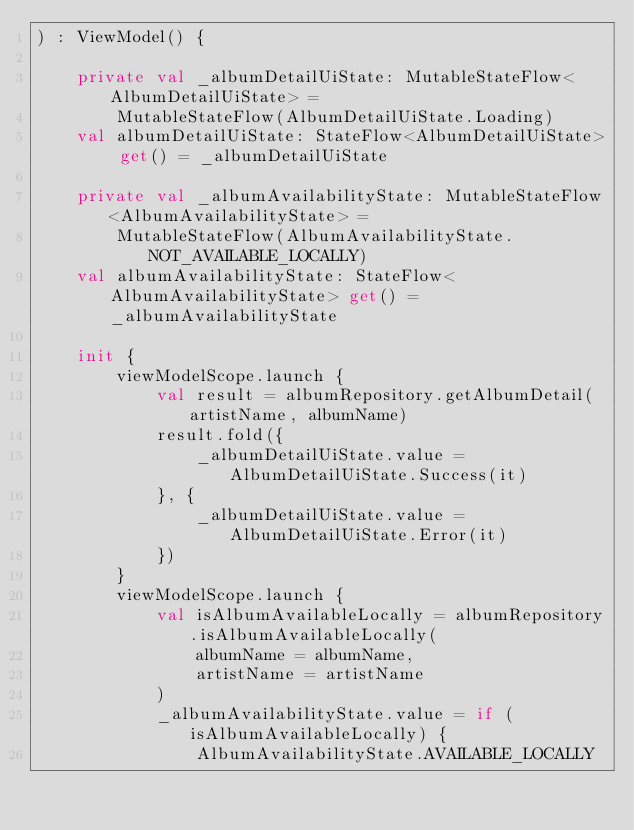<code> <loc_0><loc_0><loc_500><loc_500><_Kotlin_>) : ViewModel() {

    private val _albumDetailUiState: MutableStateFlow<AlbumDetailUiState> =
        MutableStateFlow(AlbumDetailUiState.Loading)
    val albumDetailUiState: StateFlow<AlbumDetailUiState> get() = _albumDetailUiState

    private val _albumAvailabilityState: MutableStateFlow<AlbumAvailabilityState> =
        MutableStateFlow(AlbumAvailabilityState.NOT_AVAILABLE_LOCALLY)
    val albumAvailabilityState: StateFlow<AlbumAvailabilityState> get() = _albumAvailabilityState

    init {
        viewModelScope.launch {
            val result = albumRepository.getAlbumDetail(artistName, albumName)
            result.fold({
                _albumDetailUiState.value = AlbumDetailUiState.Success(it)
            }, {
                _albumDetailUiState.value = AlbumDetailUiState.Error(it)
            })
        }
        viewModelScope.launch {
            val isAlbumAvailableLocally = albumRepository.isAlbumAvailableLocally(
                albumName = albumName,
                artistName = artistName
            )
            _albumAvailabilityState.value = if (isAlbumAvailableLocally) {
                AlbumAvailabilityState.AVAILABLE_LOCALLY</code> 